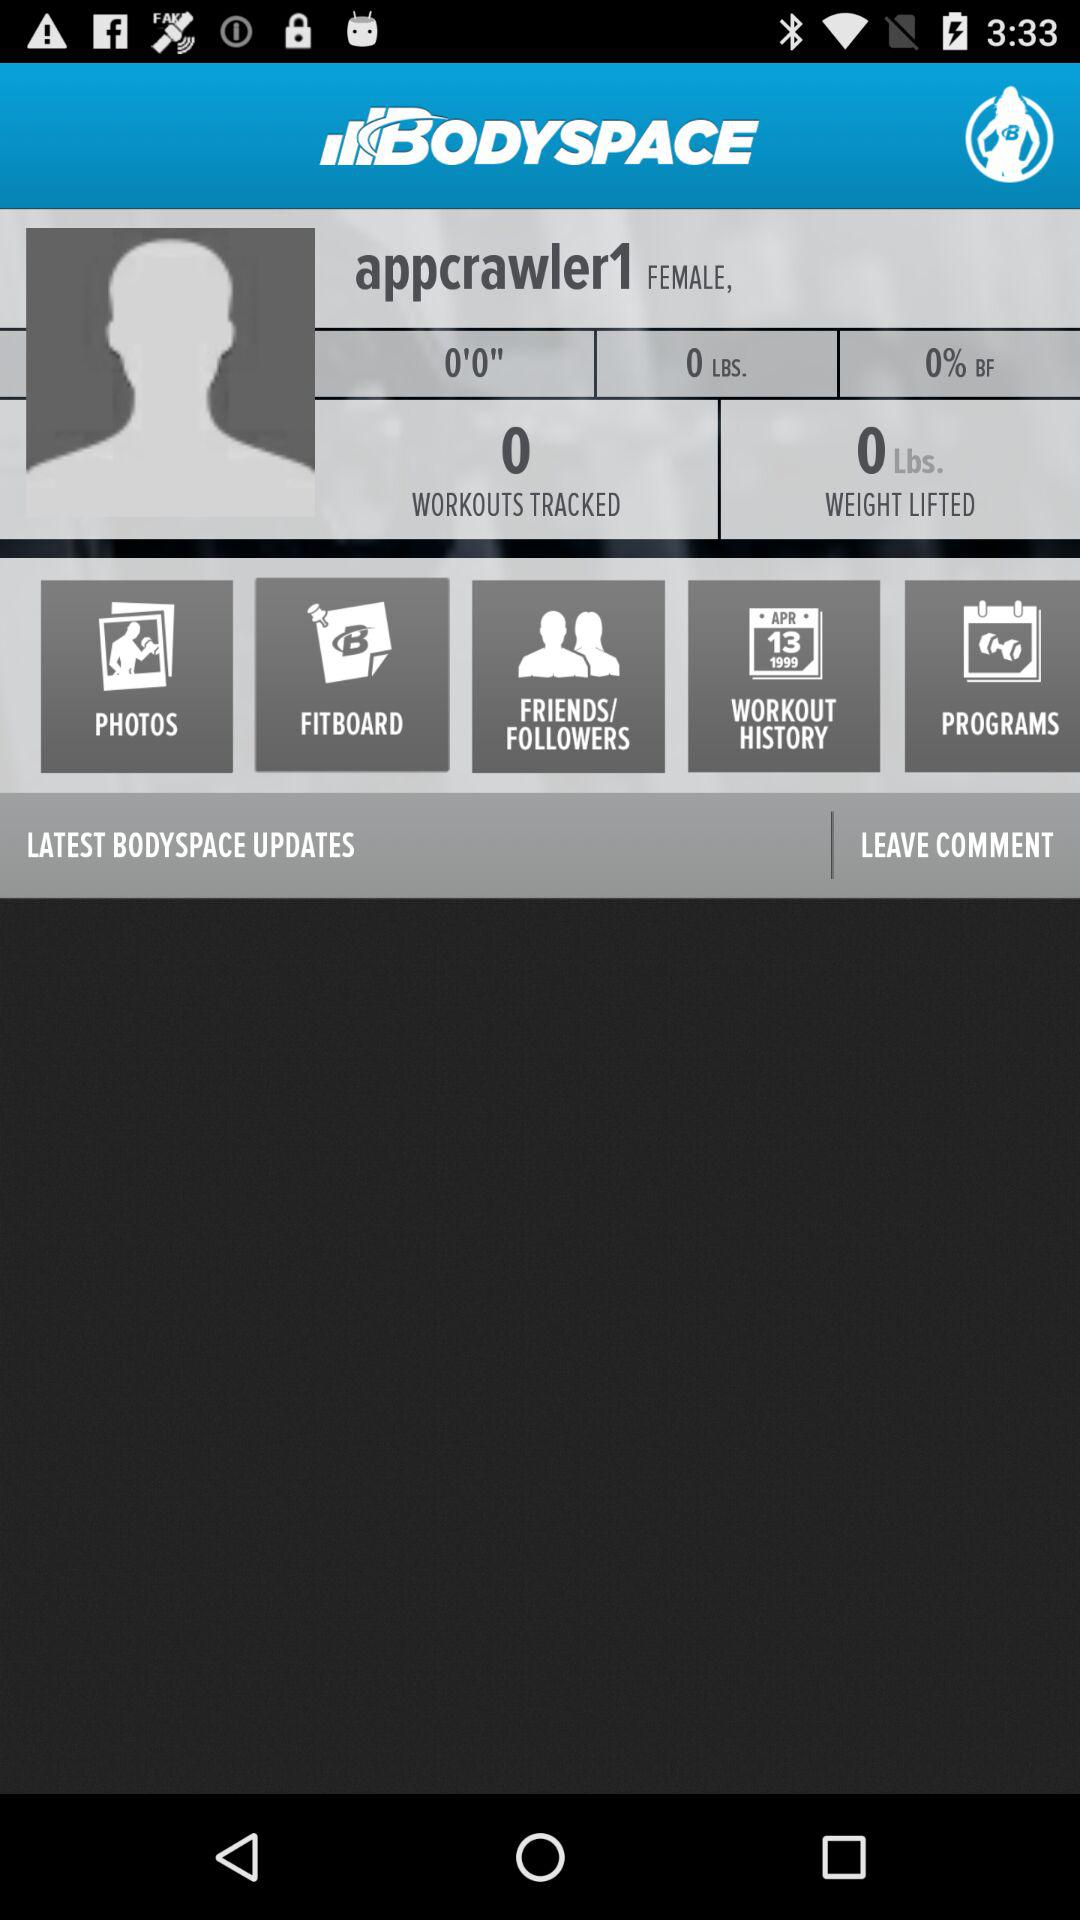What is the username? The username is "appcrawler1". 